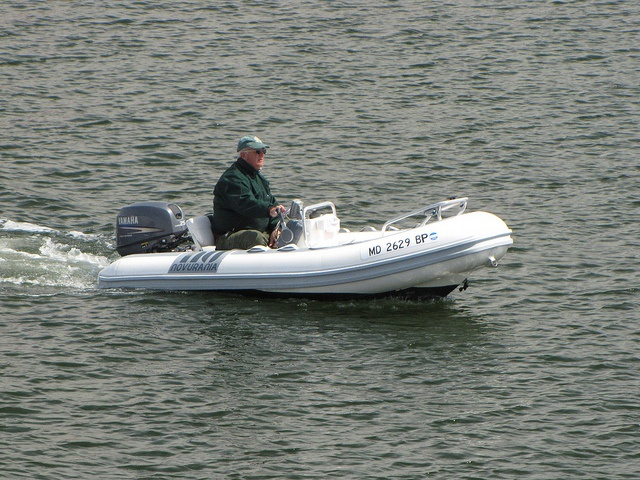Describe the objects in this image and their specific colors. I can see boat in gray, white, darkgray, and black tones and people in gray, black, teal, and darkgray tones in this image. 